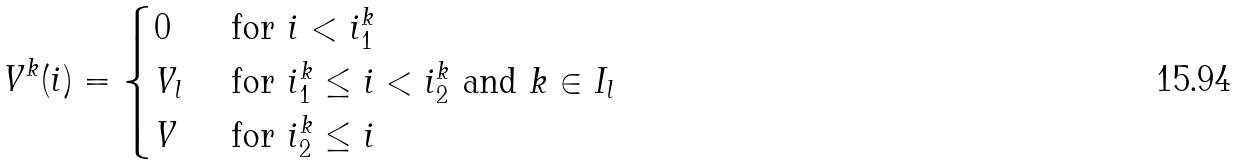<formula> <loc_0><loc_0><loc_500><loc_500>V ^ { k } ( i ) = \begin{cases} 0 & \text { for } i < i _ { 1 } ^ { k } \\ V _ { l } & \text { for } i _ { 1 } ^ { k } \leq i < i _ { 2 } ^ { k } \text { and } k \in I _ { l } \\ V & \text { for } i _ { 2 } ^ { k } \leq i \end{cases}</formula> 